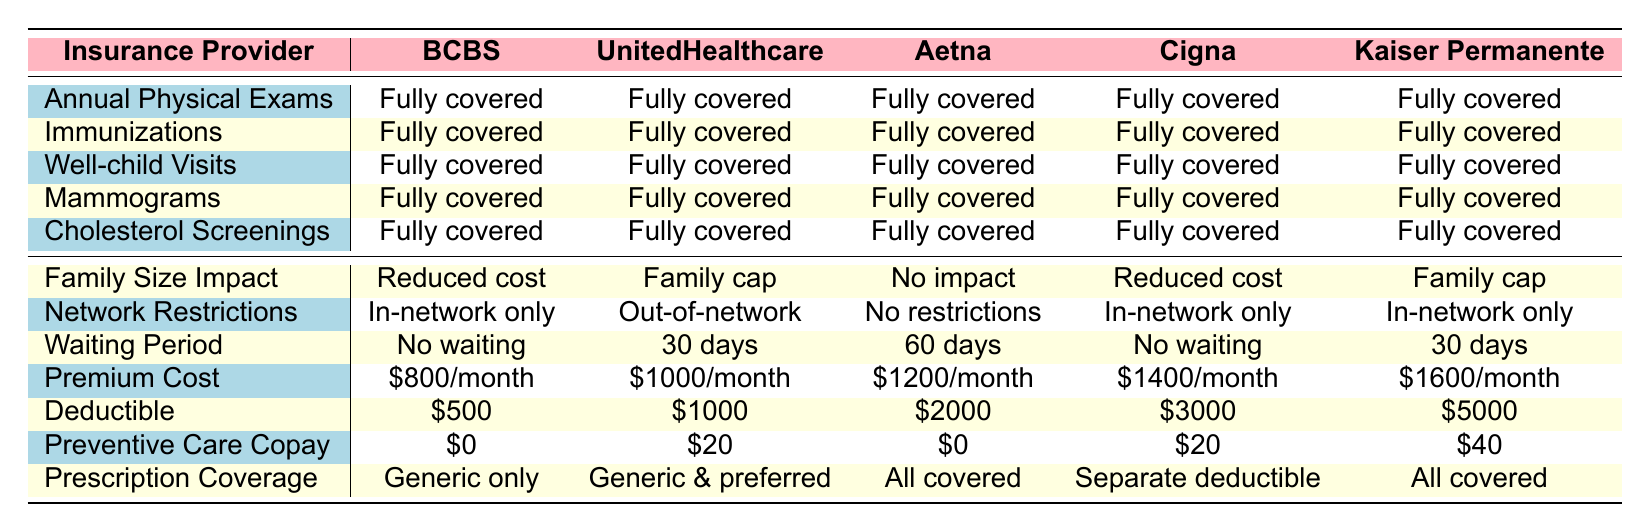What preventive care benefits are fully covered by all insurance providers? All insurance providers list five preventive care benefits: Annual physical exams, Immunizations, Well-child visits, Mammograms, and Cholesterol screenings, all of which are fully covered.
Answer: All benefits Which insurance provider has the highest premium cost? Looking at the premium costs listed for each provider, Kaiser Permanente has the highest monthly premium at $1600.
Answer: Kaiser Permanente Is there any insurance provider that covers preventive care with a separate deductible for prescriptions? The table indicates that Cigna has separate prescription deductible coverage while providing comprehensive preventive care benefits that are fully covered.
Answer: Yes, Cigna What is the average deductible across all insurance providers? The deductibles are $500, $1000, $2000, $3000, and $5000. Adding these together gives $500 + $1000 + $2000 + $3000 + $5000 = $15000. Dividing by the number of providers (5) gives an average of $15000 / 5 = $3000.
Answer: $3000 Which provider has a shorter waiting period, UnitedHealthcare or Kaiser Permanente? UnitedHealthcare has a waiting period of 30 days, while Kaiser Permanente has no waiting period at all. Since no waiting (0 days) is shorter than 30 days, Kaiser Permanente has the shorter waiting period.
Answer: Kaiser Permanente 